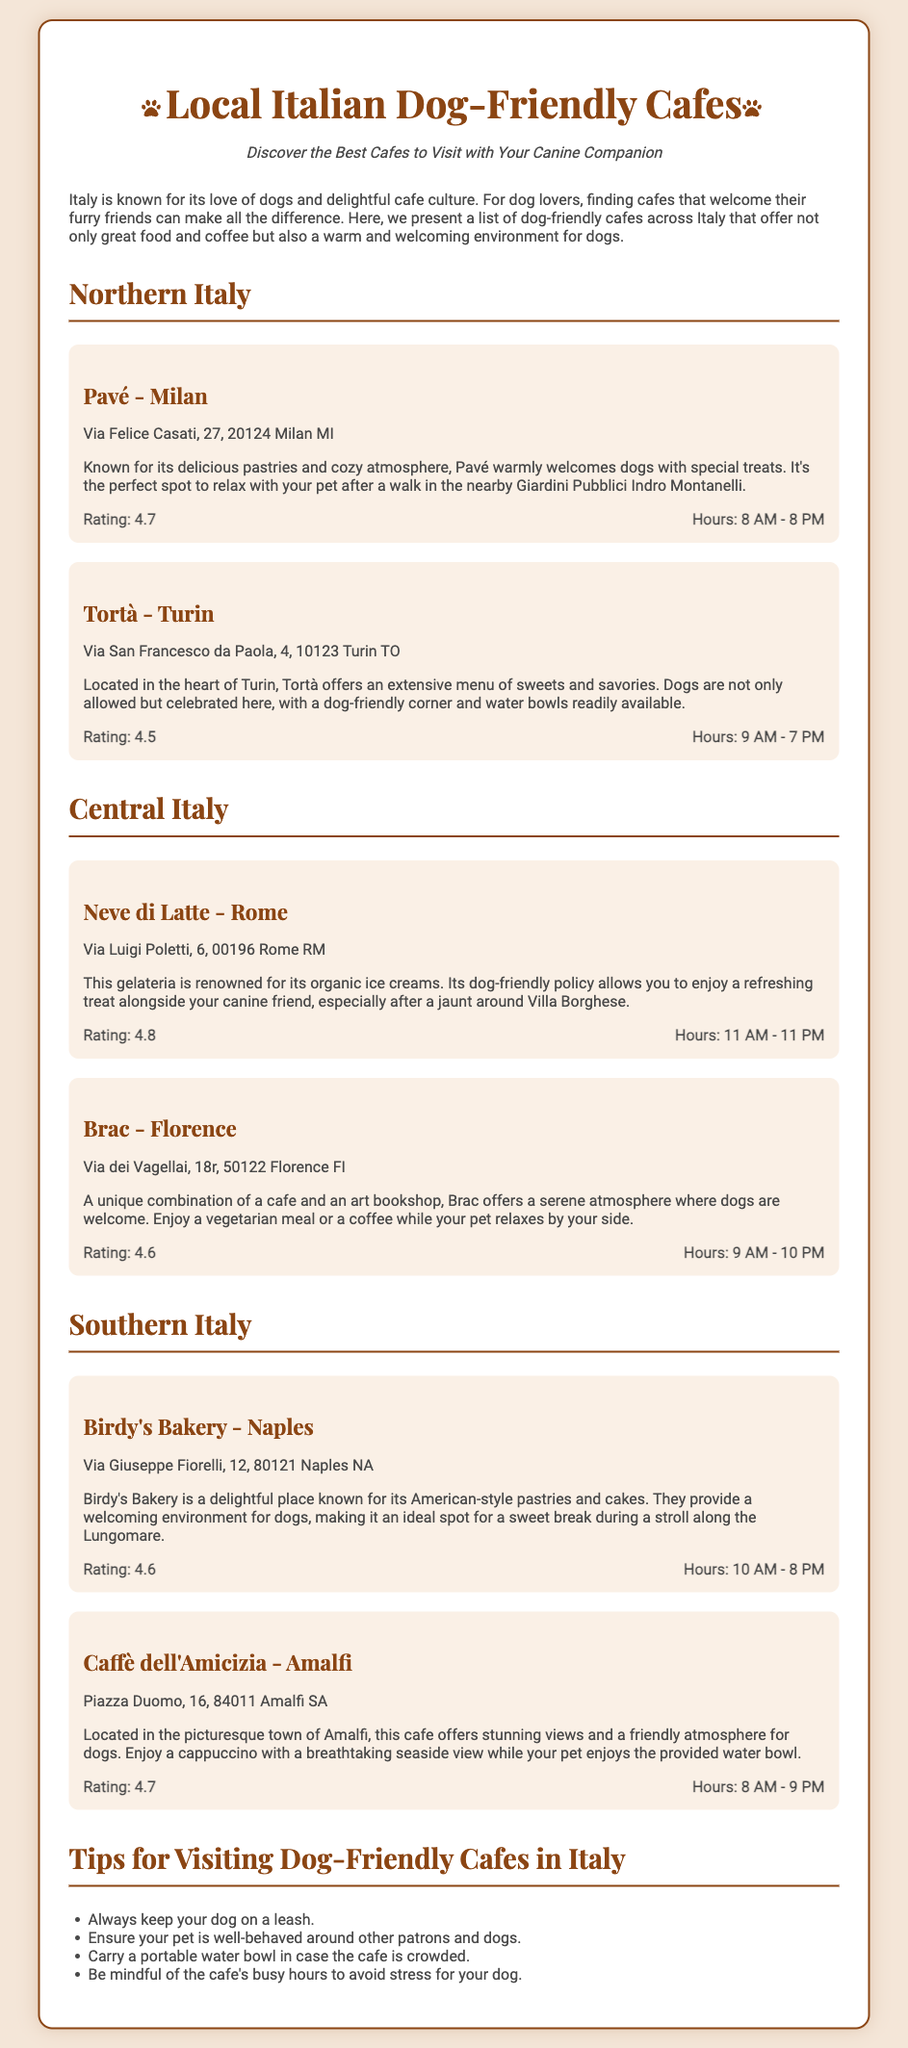what is the rating of Pavé - Milan? The rating is directly mentioned under the cafe details section in the document.
Answer: 4.7 what time does Tortà in Turin open? The opening hours are specified in the cafe details section for each cafe.
Answer: 9 AM what dog-friendly treat does Pavé offer? The document states that Pavé offers special treats for dogs.
Answer: Special treats which cafe has the highest rating? To find this, I look at the ratings provided under each cafe's details.
Answer: Neve di Latte where is Birdy's Bakery located? The address is explicitly listed under the cafe's name.
Answer: Via Giuseppe Fiorelli, 12, 80121 Naples NA what common tip is given for visiting dog-friendly cafes? The tips are listed in a separate section, and common practice is implied.
Answer: Keep your dog on a leash which café is the perfect spot after a walk in Giardini Pubblici Indro Montanelli? The document provides information about suitable cafes after mentioned locations.
Answer: Pavé - Milan how late does Caffè dell'Amicizia stay open? The closing hours are found in the cafe details section.
Answer: 9 PM 